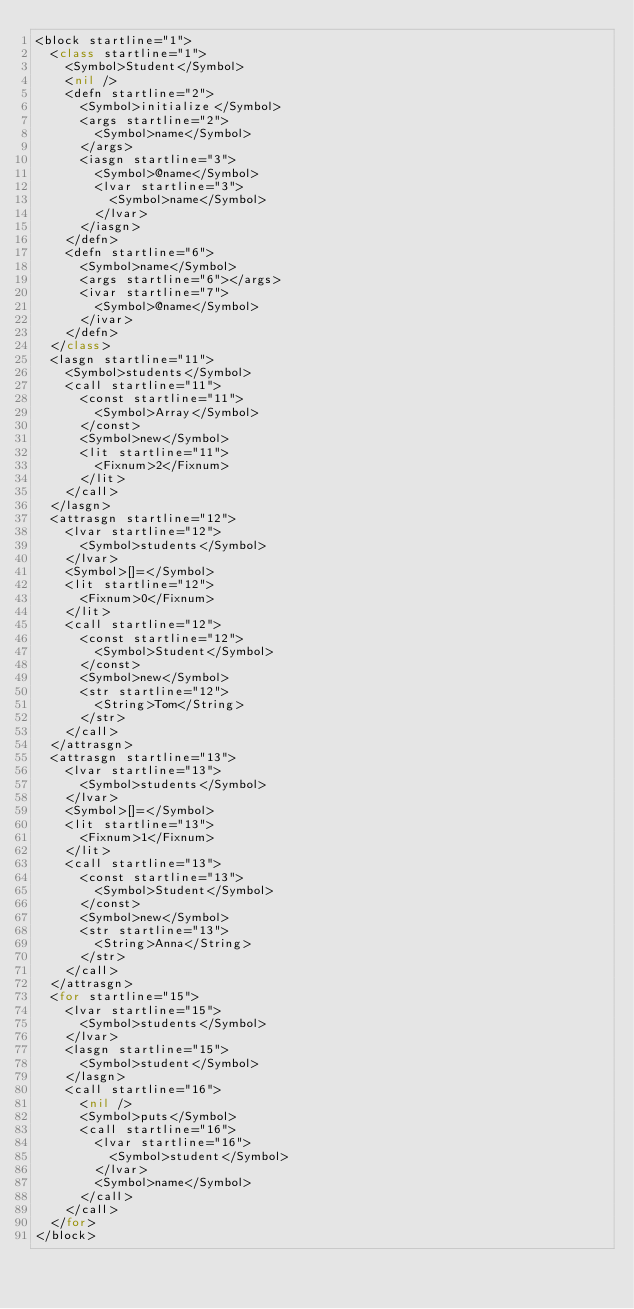<code> <loc_0><loc_0><loc_500><loc_500><_Ruby_><block startline="1">
  <class startline="1">
    <Symbol>Student</Symbol>
    <nil />
    <defn startline="2">
      <Symbol>initialize</Symbol>
      <args startline="2">
        <Symbol>name</Symbol>
      </args>
      <iasgn startline="3">
        <Symbol>@name</Symbol>
        <lvar startline="3">
          <Symbol>name</Symbol>
        </lvar>
      </iasgn>
    </defn>
    <defn startline="6">
      <Symbol>name</Symbol>
      <args startline="6"></args>
      <ivar startline="7">
        <Symbol>@name</Symbol>
      </ivar>
    </defn>
  </class>
  <lasgn startline="11">
    <Symbol>students</Symbol>
    <call startline="11">
      <const startline="11">
        <Symbol>Array</Symbol>
      </const>
      <Symbol>new</Symbol>
      <lit startline="11">
        <Fixnum>2</Fixnum>
      </lit>
    </call>
  </lasgn>
  <attrasgn startline="12">
    <lvar startline="12">
      <Symbol>students</Symbol>
    </lvar>
    <Symbol>[]=</Symbol>
    <lit startline="12">
      <Fixnum>0</Fixnum>
    </lit>
    <call startline="12">
      <const startline="12">
        <Symbol>Student</Symbol>
      </const>
      <Symbol>new</Symbol>
      <str startline="12">
        <String>Tom</String>
      </str>
    </call>
  </attrasgn>
  <attrasgn startline="13">
    <lvar startline="13">
      <Symbol>students</Symbol>
    </lvar>
    <Symbol>[]=</Symbol>
    <lit startline="13">
      <Fixnum>1</Fixnum>
    </lit>
    <call startline="13">
      <const startline="13">
        <Symbol>Student</Symbol>
      </const>
      <Symbol>new</Symbol>
      <str startline="13">
        <String>Anna</String>
      </str>
    </call>
  </attrasgn>
  <for startline="15">
    <lvar startline="15">
      <Symbol>students</Symbol>
    </lvar>
    <lasgn startline="15">
      <Symbol>student</Symbol>
    </lasgn>
    <call startline="16">
      <nil />
      <Symbol>puts</Symbol>
      <call startline="16">
        <lvar startline="16">
          <Symbol>student</Symbol>
        </lvar>
        <Symbol>name</Symbol>
      </call>
    </call>
  </for>
</block></code> 